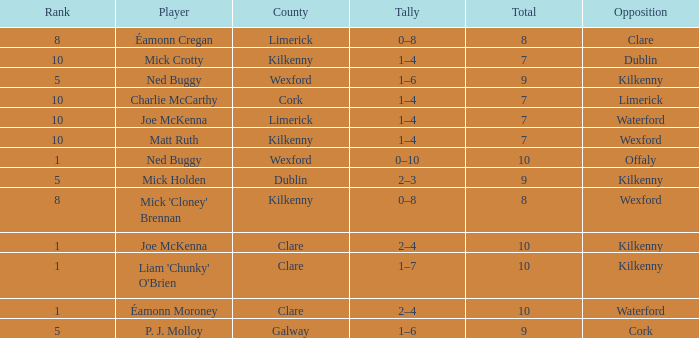Which Total has a County of kilkenny, and a Tally of 1–4, and a Rank larger than 10? None. 